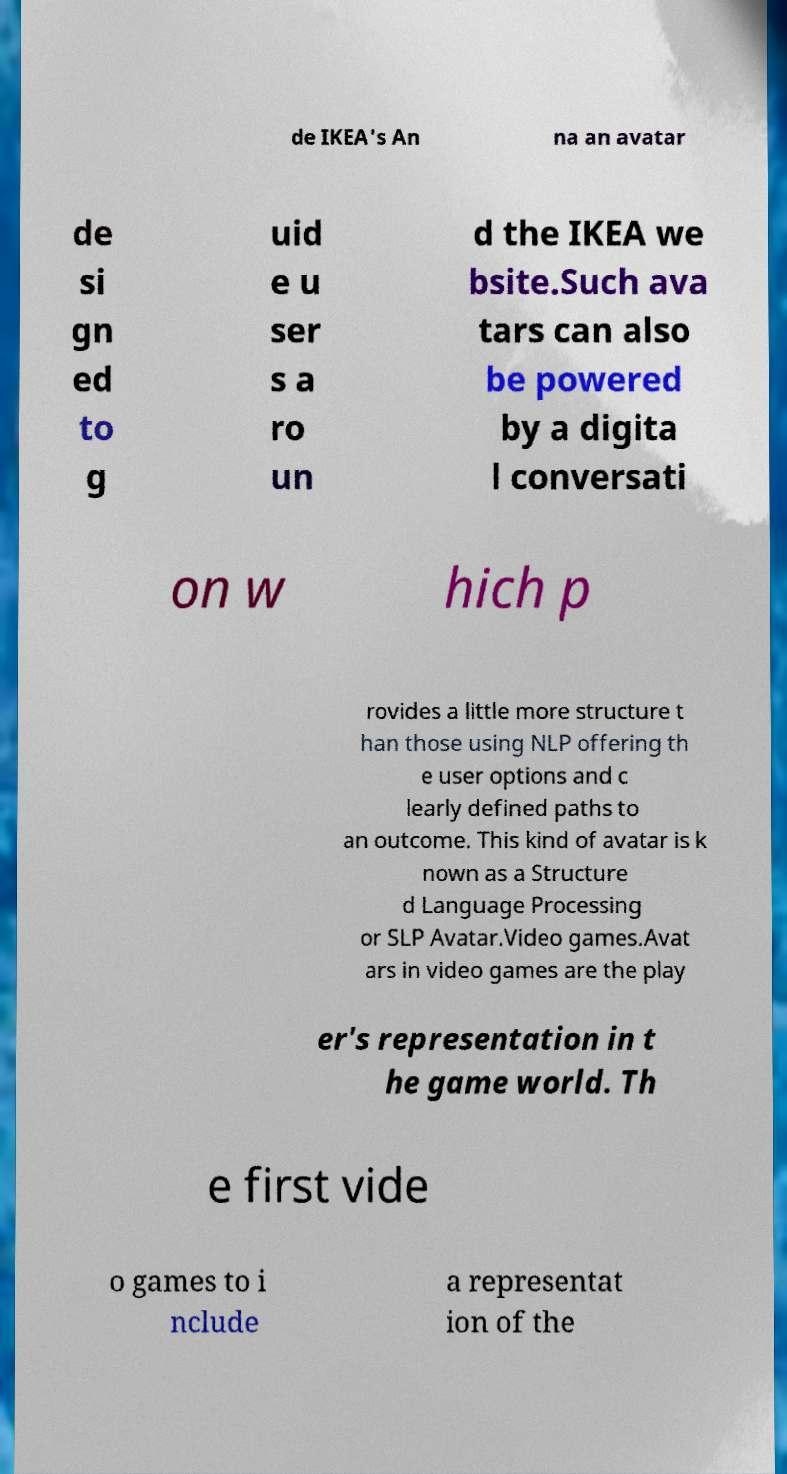Can you read and provide the text displayed in the image?This photo seems to have some interesting text. Can you extract and type it out for me? de IKEA's An na an avatar de si gn ed to g uid e u ser s a ro un d the IKEA we bsite.Such ava tars can also be powered by a digita l conversati on w hich p rovides a little more structure t han those using NLP offering th e user options and c learly defined paths to an outcome. This kind of avatar is k nown as a Structure d Language Processing or SLP Avatar.Video games.Avat ars in video games are the play er's representation in t he game world. Th e first vide o games to i nclude a representat ion of the 